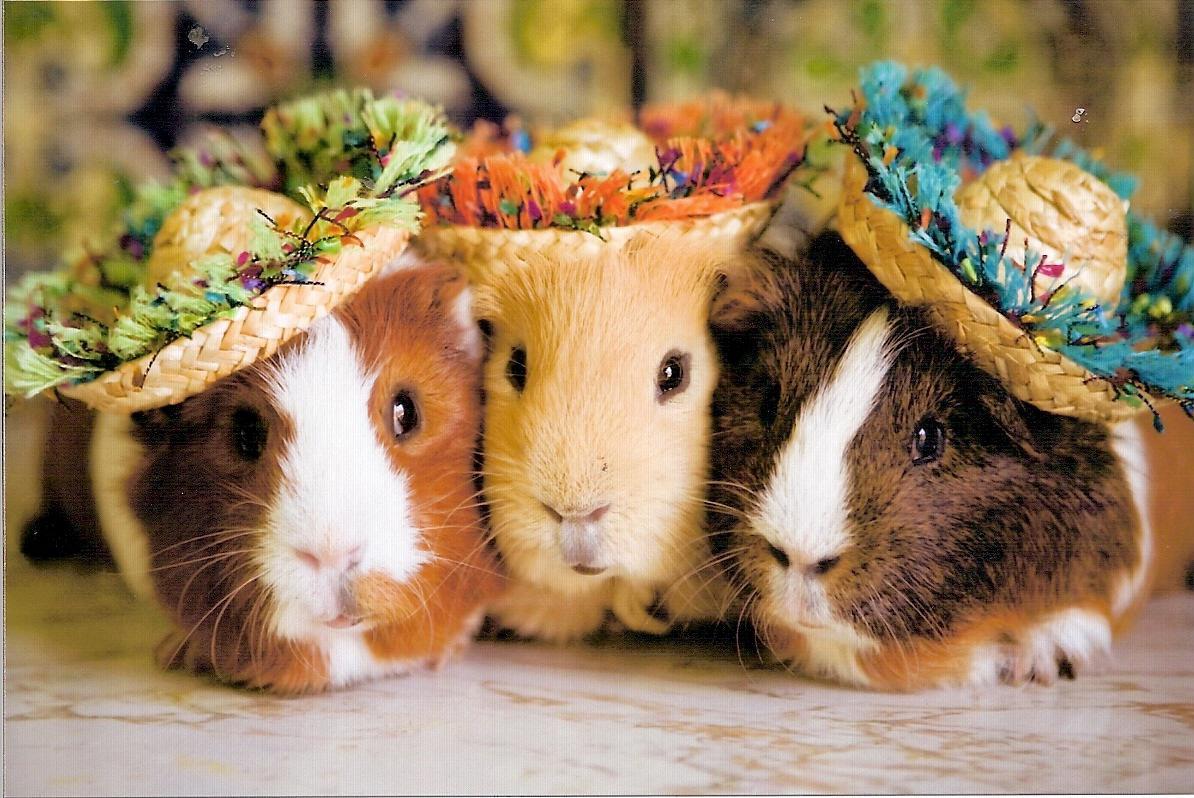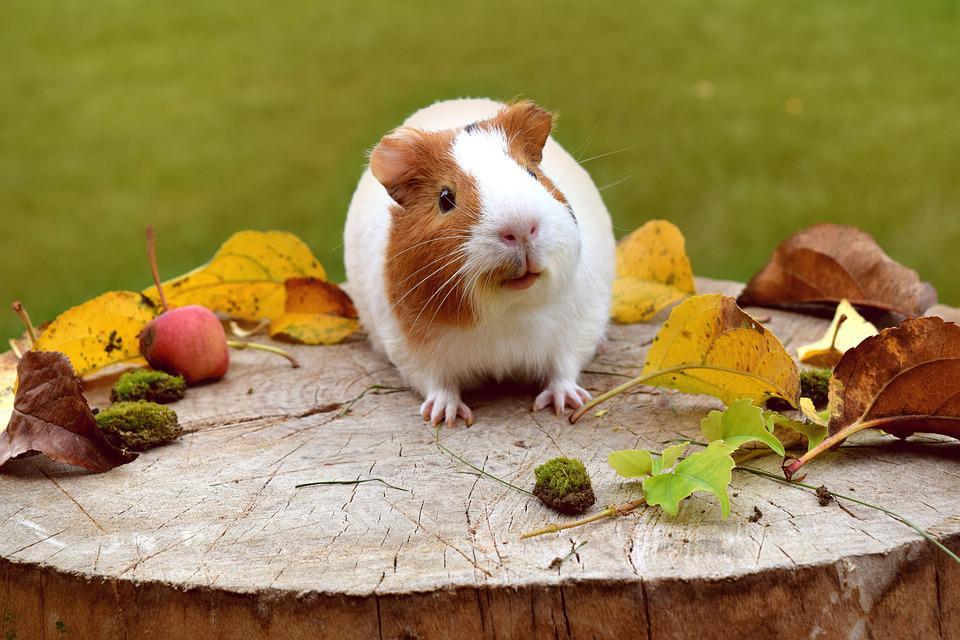The first image is the image on the left, the second image is the image on the right. For the images displayed, is the sentence "One of the images shows only one hamster wearing something on its head." factually correct? Answer yes or no. No. The first image is the image on the left, the second image is the image on the right. Considering the images on both sides, is "An image shows just one hamster wearing something decorative on its head." valid? Answer yes or no. No. 